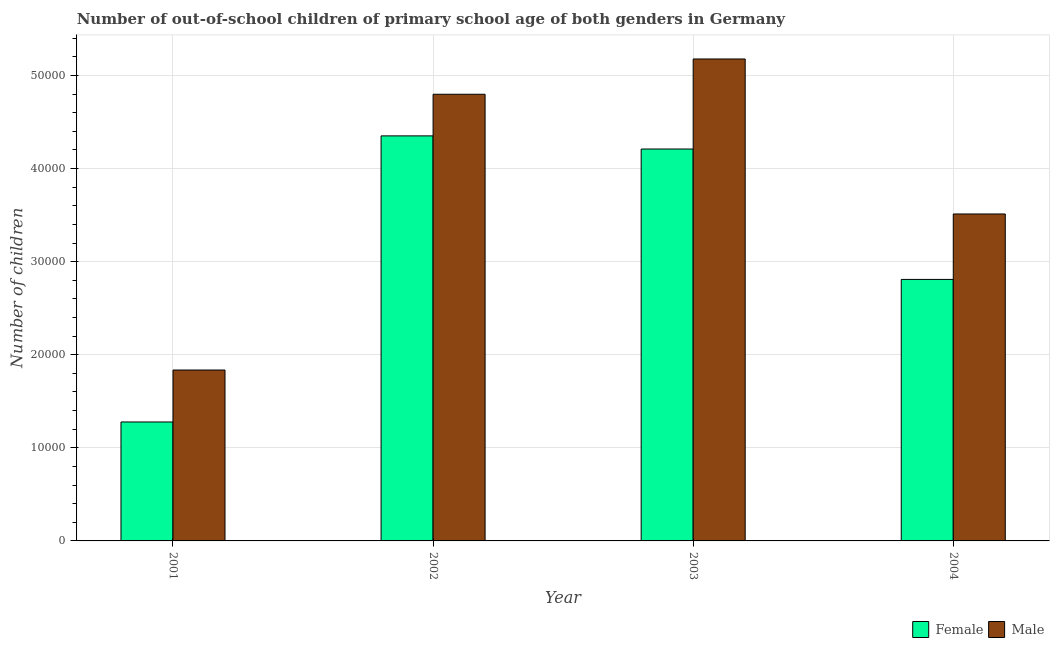How many groups of bars are there?
Your answer should be very brief. 4. How many bars are there on the 3rd tick from the right?
Make the answer very short. 2. What is the number of female out-of-school students in 2004?
Ensure brevity in your answer.  2.81e+04. Across all years, what is the maximum number of female out-of-school students?
Provide a succinct answer. 4.35e+04. Across all years, what is the minimum number of female out-of-school students?
Your answer should be very brief. 1.28e+04. What is the total number of female out-of-school students in the graph?
Give a very brief answer. 1.26e+05. What is the difference between the number of female out-of-school students in 2003 and that in 2004?
Provide a succinct answer. 1.40e+04. What is the difference between the number of male out-of-school students in 2004 and the number of female out-of-school students in 2002?
Offer a very short reply. -1.29e+04. What is the average number of male out-of-school students per year?
Give a very brief answer. 3.83e+04. What is the ratio of the number of male out-of-school students in 2001 to that in 2002?
Provide a succinct answer. 0.38. What is the difference between the highest and the second highest number of female out-of-school students?
Your answer should be very brief. 1411. What is the difference between the highest and the lowest number of female out-of-school students?
Ensure brevity in your answer.  3.07e+04. How many bars are there?
Your answer should be compact. 8. How many years are there in the graph?
Keep it short and to the point. 4. Are the values on the major ticks of Y-axis written in scientific E-notation?
Keep it short and to the point. No. Does the graph contain grids?
Provide a succinct answer. Yes. Where does the legend appear in the graph?
Offer a very short reply. Bottom right. What is the title of the graph?
Make the answer very short. Number of out-of-school children of primary school age of both genders in Germany. What is the label or title of the Y-axis?
Your answer should be very brief. Number of children. What is the Number of children in Female in 2001?
Provide a succinct answer. 1.28e+04. What is the Number of children in Male in 2001?
Offer a very short reply. 1.84e+04. What is the Number of children in Female in 2002?
Provide a succinct answer. 4.35e+04. What is the Number of children in Male in 2002?
Offer a terse response. 4.80e+04. What is the Number of children in Female in 2003?
Your answer should be very brief. 4.21e+04. What is the Number of children of Male in 2003?
Ensure brevity in your answer.  5.18e+04. What is the Number of children in Female in 2004?
Ensure brevity in your answer.  2.81e+04. What is the Number of children of Male in 2004?
Provide a short and direct response. 3.51e+04. Across all years, what is the maximum Number of children in Female?
Offer a terse response. 4.35e+04. Across all years, what is the maximum Number of children of Male?
Offer a terse response. 5.18e+04. Across all years, what is the minimum Number of children of Female?
Provide a short and direct response. 1.28e+04. Across all years, what is the minimum Number of children in Male?
Your answer should be very brief. 1.84e+04. What is the total Number of children in Female in the graph?
Your answer should be very brief. 1.26e+05. What is the total Number of children of Male in the graph?
Keep it short and to the point. 1.53e+05. What is the difference between the Number of children of Female in 2001 and that in 2002?
Make the answer very short. -3.07e+04. What is the difference between the Number of children in Male in 2001 and that in 2002?
Your response must be concise. -2.96e+04. What is the difference between the Number of children in Female in 2001 and that in 2003?
Keep it short and to the point. -2.93e+04. What is the difference between the Number of children of Male in 2001 and that in 2003?
Provide a succinct answer. -3.34e+04. What is the difference between the Number of children of Female in 2001 and that in 2004?
Make the answer very short. -1.53e+04. What is the difference between the Number of children in Male in 2001 and that in 2004?
Offer a terse response. -1.68e+04. What is the difference between the Number of children of Female in 2002 and that in 2003?
Provide a short and direct response. 1411. What is the difference between the Number of children of Male in 2002 and that in 2003?
Offer a terse response. -3790. What is the difference between the Number of children in Female in 2002 and that in 2004?
Keep it short and to the point. 1.54e+04. What is the difference between the Number of children in Male in 2002 and that in 2004?
Offer a terse response. 1.29e+04. What is the difference between the Number of children of Female in 2003 and that in 2004?
Give a very brief answer. 1.40e+04. What is the difference between the Number of children of Male in 2003 and that in 2004?
Offer a very short reply. 1.66e+04. What is the difference between the Number of children of Female in 2001 and the Number of children of Male in 2002?
Your response must be concise. -3.52e+04. What is the difference between the Number of children in Female in 2001 and the Number of children in Male in 2003?
Your answer should be compact. -3.90e+04. What is the difference between the Number of children in Female in 2001 and the Number of children in Male in 2004?
Ensure brevity in your answer.  -2.23e+04. What is the difference between the Number of children of Female in 2002 and the Number of children of Male in 2003?
Your answer should be compact. -8262. What is the difference between the Number of children of Female in 2002 and the Number of children of Male in 2004?
Offer a very short reply. 8387. What is the difference between the Number of children of Female in 2003 and the Number of children of Male in 2004?
Keep it short and to the point. 6976. What is the average Number of children of Female per year?
Offer a very short reply. 3.16e+04. What is the average Number of children of Male per year?
Give a very brief answer. 3.83e+04. In the year 2001, what is the difference between the Number of children of Female and Number of children of Male?
Keep it short and to the point. -5581. In the year 2002, what is the difference between the Number of children in Female and Number of children in Male?
Your answer should be very brief. -4472. In the year 2003, what is the difference between the Number of children of Female and Number of children of Male?
Keep it short and to the point. -9673. In the year 2004, what is the difference between the Number of children of Female and Number of children of Male?
Keep it short and to the point. -7030. What is the ratio of the Number of children in Female in 2001 to that in 2002?
Your answer should be very brief. 0.29. What is the ratio of the Number of children in Male in 2001 to that in 2002?
Ensure brevity in your answer.  0.38. What is the ratio of the Number of children in Female in 2001 to that in 2003?
Provide a short and direct response. 0.3. What is the ratio of the Number of children in Male in 2001 to that in 2003?
Ensure brevity in your answer.  0.35. What is the ratio of the Number of children of Female in 2001 to that in 2004?
Provide a short and direct response. 0.45. What is the ratio of the Number of children in Male in 2001 to that in 2004?
Keep it short and to the point. 0.52. What is the ratio of the Number of children of Female in 2002 to that in 2003?
Ensure brevity in your answer.  1.03. What is the ratio of the Number of children in Male in 2002 to that in 2003?
Keep it short and to the point. 0.93. What is the ratio of the Number of children in Female in 2002 to that in 2004?
Make the answer very short. 1.55. What is the ratio of the Number of children in Male in 2002 to that in 2004?
Your answer should be compact. 1.37. What is the ratio of the Number of children of Female in 2003 to that in 2004?
Your answer should be very brief. 1.5. What is the ratio of the Number of children in Male in 2003 to that in 2004?
Provide a succinct answer. 1.47. What is the difference between the highest and the second highest Number of children in Female?
Ensure brevity in your answer.  1411. What is the difference between the highest and the second highest Number of children in Male?
Offer a terse response. 3790. What is the difference between the highest and the lowest Number of children in Female?
Give a very brief answer. 3.07e+04. What is the difference between the highest and the lowest Number of children of Male?
Give a very brief answer. 3.34e+04. 